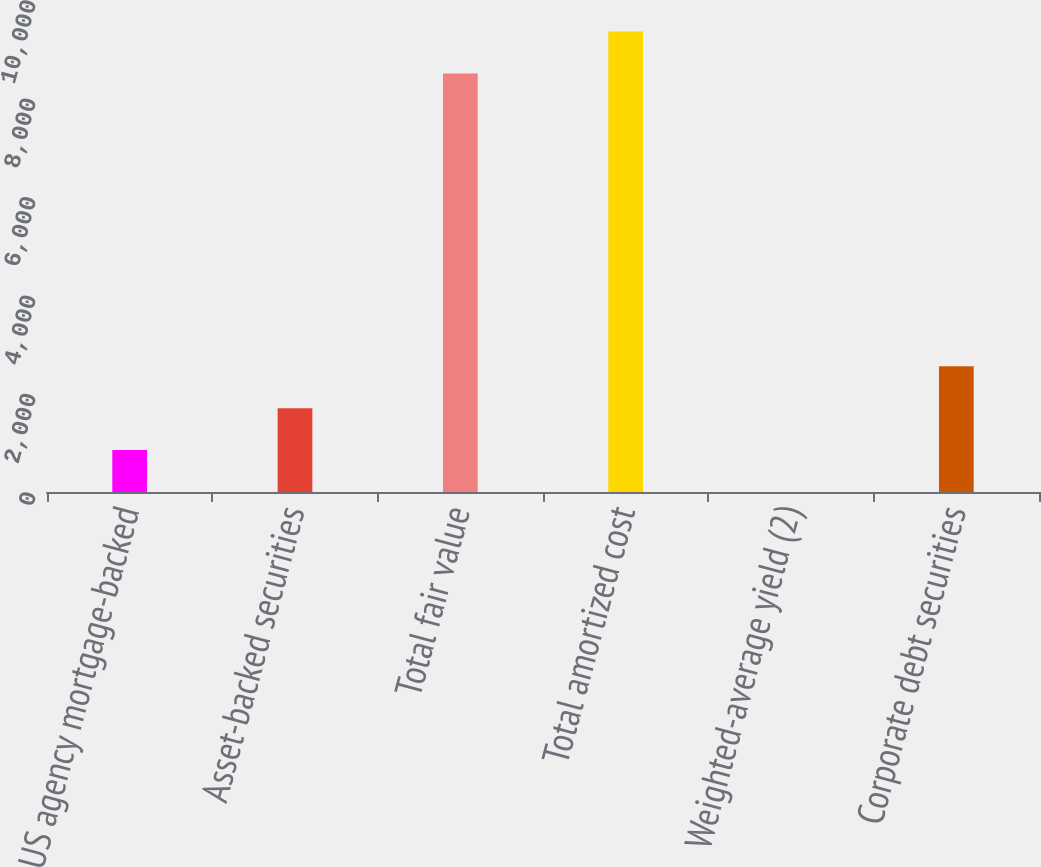Convert chart to OTSL. <chart><loc_0><loc_0><loc_500><loc_500><bar_chart><fcel>US agency mortgage-backed<fcel>Asset-backed securities<fcel>Total fair value<fcel>Total amortized cost<fcel>Weighted-average yield (2)<fcel>Corporate debt securities<nl><fcel>853.08<fcel>1704.63<fcel>8508<fcel>9359.55<fcel>1.53<fcel>2556.18<nl></chart> 